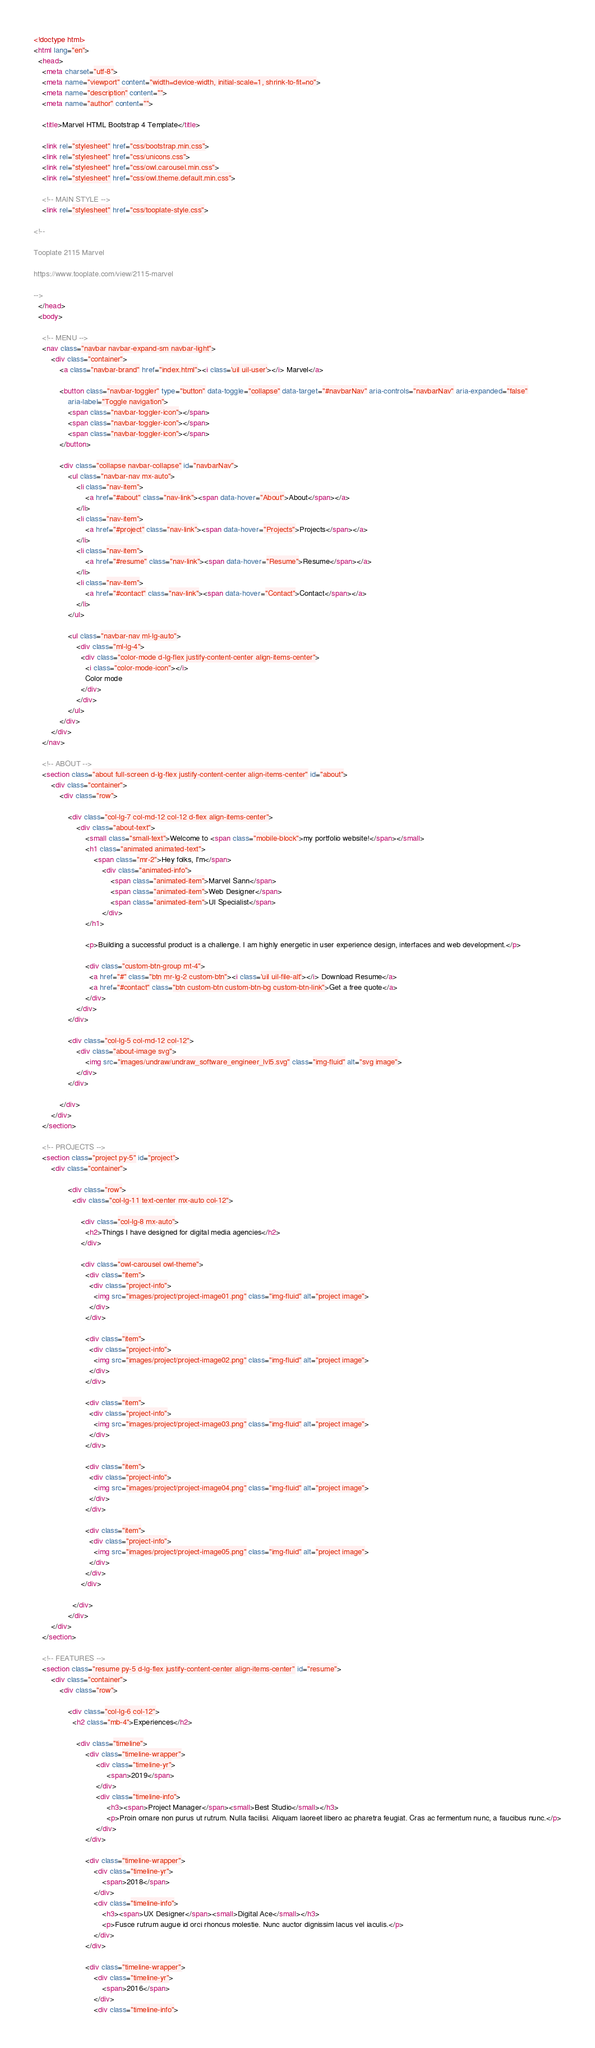<code> <loc_0><loc_0><loc_500><loc_500><_HTML_><!doctype html>
<html lang="en">
  <head>
    <meta charset="utf-8">
    <meta name="viewport" content="width=device-width, initial-scale=1, shrink-to-fit=no">
    <meta name="description" content="">
    <meta name="author" content="">

    <title>Marvel HTML Bootstrap 4 Template</title>

    <link rel="stylesheet" href="css/bootstrap.min.css">
    <link rel="stylesheet" href="css/unicons.css">
    <link rel="stylesheet" href="css/owl.carousel.min.css">
    <link rel="stylesheet" href="css/owl.theme.default.min.css">

    <!-- MAIN STYLE -->
    <link rel="stylesheet" href="css/tooplate-style.css">
    
<!--

Tooplate 2115 Marvel

https://www.tooplate.com/view/2115-marvel

-->
  </head>
  <body>

    <!-- MENU -->
    <nav class="navbar navbar-expand-sm navbar-light">
        <div class="container">
            <a class="navbar-brand" href="index.html"><i class='uil uil-user'></i> Marvel</a>

            <button class="navbar-toggler" type="button" data-toggle="collapse" data-target="#navbarNav" aria-controls="navbarNav" aria-expanded="false"
                aria-label="Toggle navigation">
                <span class="navbar-toggler-icon"></span>
                <span class="navbar-toggler-icon"></span>
                <span class="navbar-toggler-icon"></span>
            </button>

            <div class="collapse navbar-collapse" id="navbarNav">
                <ul class="navbar-nav mx-auto">
                    <li class="nav-item">
                        <a href="#about" class="nav-link"><span data-hover="About">About</span></a>
                    </li>
                    <li class="nav-item">
                        <a href="#project" class="nav-link"><span data-hover="Projects">Projects</span></a>
                    </li>
                    <li class="nav-item">
                        <a href="#resume" class="nav-link"><span data-hover="Resume">Resume</span></a>
                    </li>
                    <li class="nav-item">
                        <a href="#contact" class="nav-link"><span data-hover="Contact">Contact</span></a>
                    </li>
                </ul>

                <ul class="navbar-nav ml-lg-auto">
                    <div class="ml-lg-4">
                      <div class="color-mode d-lg-flex justify-content-center align-items-center">
                        <i class="color-mode-icon"></i>
                        Color mode
                      </div>
                    </div>
                </ul>
            </div>
        </div>
    </nav>

    <!-- ABOUT -->
    <section class="about full-screen d-lg-flex justify-content-center align-items-center" id="about">
        <div class="container">
            <div class="row">
                
                <div class="col-lg-7 col-md-12 col-12 d-flex align-items-center">
                    <div class="about-text">
                        <small class="small-text">Welcome to <span class="mobile-block">my portfolio website!</span></small>
                        <h1 class="animated animated-text">
                            <span class="mr-2">Hey folks, I'm</span>
                                <div class="animated-info">
                                    <span class="animated-item">Marvel Sann</span>
                                    <span class="animated-item">Web Designer</span>
                                    <span class="animated-item">UI Specialist</span>
                                </div>
                        </h1>

                        <p>Building a successful product is a challenge. I am highly energetic in user experience design, interfaces and web development.</p>
                        
                        <div class="custom-btn-group mt-4">
                          <a href="#" class="btn mr-lg-2 custom-btn"><i class='uil uil-file-alt'></i> Download Resume</a>
                          <a href="#contact" class="btn custom-btn custom-btn-bg custom-btn-link">Get a free quote</a>
                        </div>
                    </div>
                </div>

                <div class="col-lg-5 col-md-12 col-12">
                    <div class="about-image svg">
                        <img src="images/undraw/undraw_software_engineer_lvl5.svg" class="img-fluid" alt="svg image">
                    </div>
                </div>

            </div>
        </div>
    </section>

    <!-- PROJECTS -->
    <section class="project py-5" id="project">
        <div class="container">
                
                <div class="row">
                  <div class="col-lg-11 text-center mx-auto col-12">

                      <div class="col-lg-8 mx-auto">
                        <h2>Things I have designed for digital media agencies</h2>
                      </div>

                      <div class="owl-carousel owl-theme">
                        <div class="item">
                          <div class="project-info">
                            <img src="images/project/project-image01.png" class="img-fluid" alt="project image">
                          </div>
                        </div>

                        <div class="item">
                          <div class="project-info">
                            <img src="images/project/project-image02.png" class="img-fluid" alt="project image">
                          </div>
                        </div>

                        <div class="item">
                          <div class="project-info">
                            <img src="images/project/project-image03.png" class="img-fluid" alt="project image">
                          </div>
                        </div>

                        <div class="item">
                          <div class="project-info">
                            <img src="images/project/project-image04.png" class="img-fluid" alt="project image">
                          </div>
                        </div>

                        <div class="item">
                          <div class="project-info">
                            <img src="images/project/project-image05.png" class="img-fluid" alt="project image">
                          </div>
                        </div>
                      </div>

                  </div>
                </div>
        </div>
    </section>

    <!-- FEATURES -->
    <section class="resume py-5 d-lg-flex justify-content-center align-items-center" id="resume">
        <div class="container">
            <div class="row">

                <div class="col-lg-6 col-12">
                  <h2 class="mb-4">Experiences</h2>

                    <div class="timeline">
                        <div class="timeline-wrapper">
                             <div class="timeline-yr">
                                  <span>2019</span>
                             </div>
                             <div class="timeline-info">
                                  <h3><span>Project Manager</span><small>Best Studio</small></h3>
                                  <p>Proin ornare non purus ut rutrum. Nulla facilisi. Aliquam laoreet libero ac pharetra feugiat. Cras ac fermentum nunc, a faucibus nunc.</p>
                             </div>
                        </div>

                        <div class="timeline-wrapper">
                            <div class="timeline-yr">
                                <span>2018</span>
                            </div>
                            <div class="timeline-info">
                                <h3><span>UX Designer</span><small>Digital Ace</small></h3>
                                <p>Fusce rutrum augue id orci rhoncus molestie. Nunc auctor dignissim lacus vel iaculis.</p>
                            </div>
                        </div>

                        <div class="timeline-wrapper">
                            <div class="timeline-yr">
                                <span>2016</span>
                            </div>
                            <div class="timeline-info"></code> 